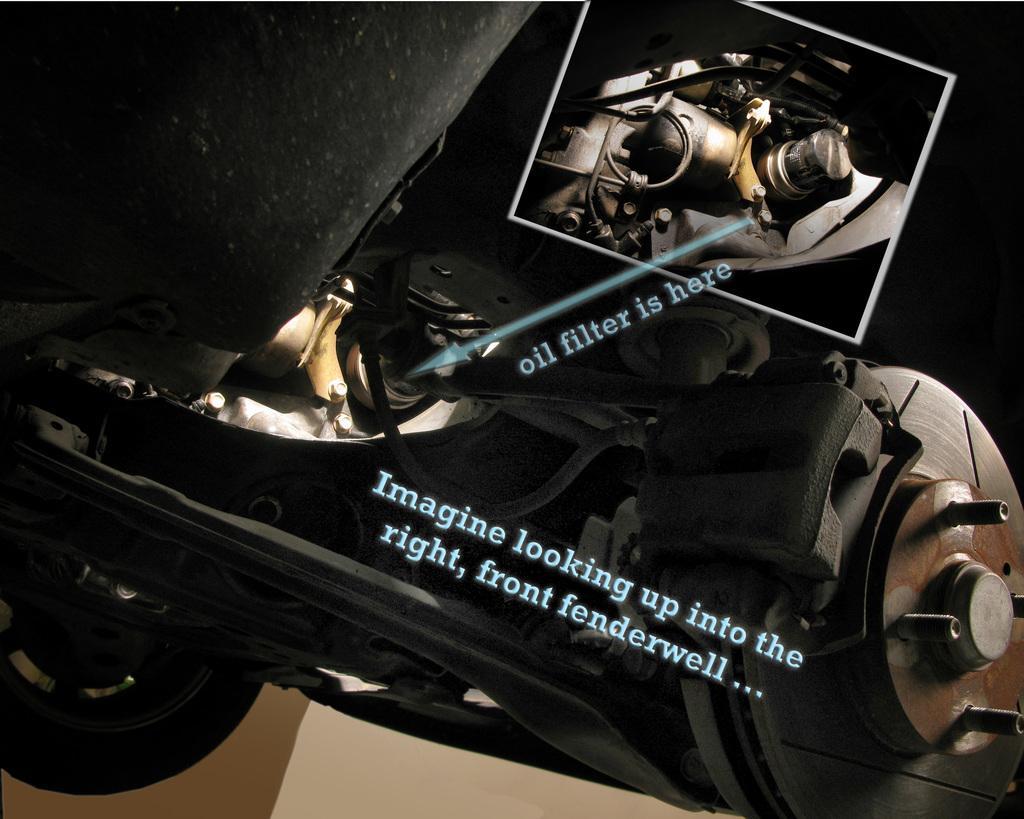How would you summarize this image in a sentence or two? This looks like an edited image. I think these are the parts of a vehicle. On the left side of the image, It looks like a wheel. I can see the letters and an arrow mark on the image. 